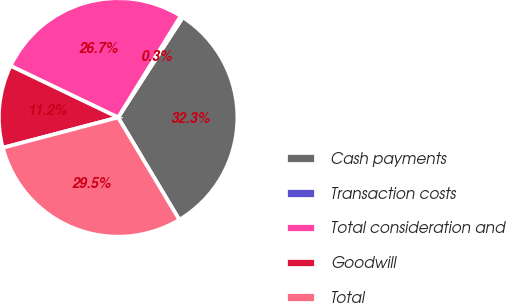<chart> <loc_0><loc_0><loc_500><loc_500><pie_chart><fcel>Cash payments<fcel>Transaction costs<fcel>Total consideration and<fcel>Goodwill<fcel>Total<nl><fcel>32.29%<fcel>0.34%<fcel>26.68%<fcel>11.21%<fcel>29.49%<nl></chart> 